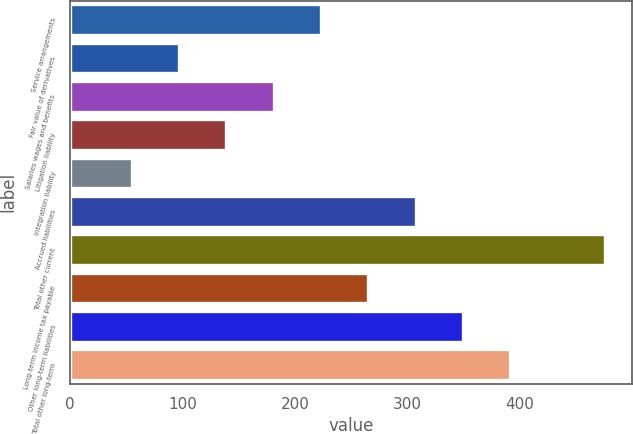Convert chart to OTSL. <chart><loc_0><loc_0><loc_500><loc_500><bar_chart><fcel>Service arrangements<fcel>Fair value of derivatives<fcel>Salaries wages and benefits<fcel>Litigation liability<fcel>Integration liability<fcel>Accrued liabilities<fcel>Total other current<fcel>Long-term income tax payable<fcel>Other long-term liabilities<fcel>Total other long-term<nl><fcel>223.04<fcel>96.86<fcel>180.98<fcel>138.92<fcel>54.8<fcel>307.16<fcel>475.4<fcel>265.1<fcel>349.22<fcel>391.28<nl></chart> 